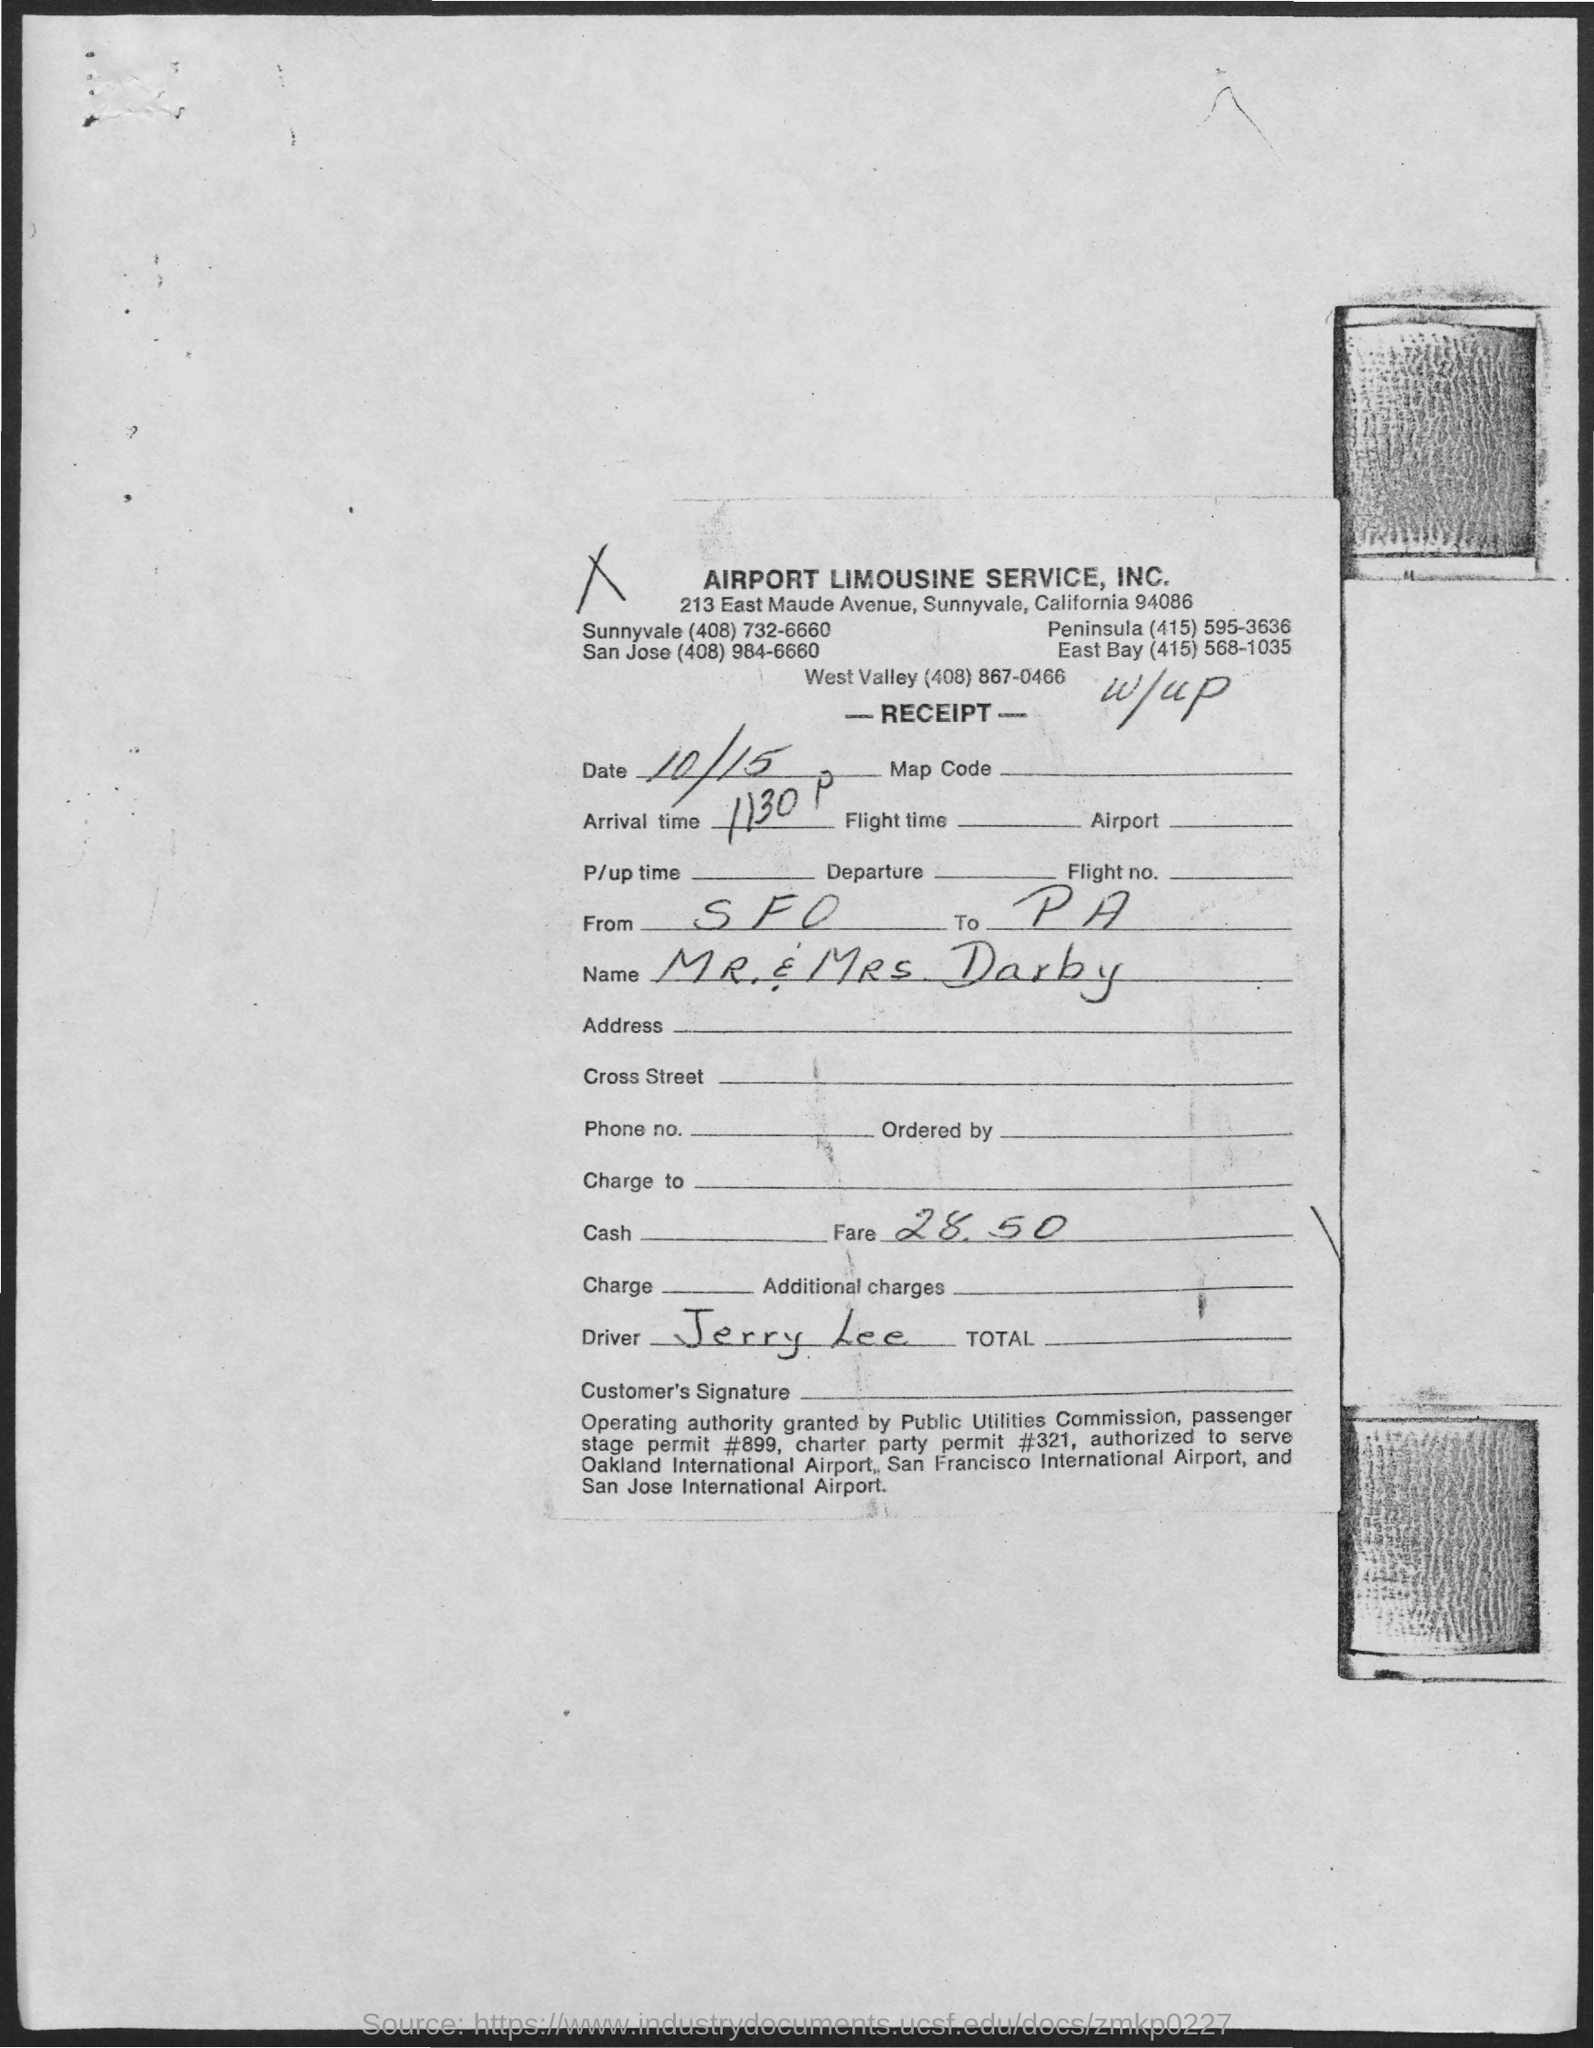What is the oraganisation name?
Make the answer very short. AIRPORT LIMOUSINE SERVICE, INC. What is the name of the traveller?
Provide a short and direct response. MR & MRS DARBY. What is the Fare amount?
Your answer should be very brief. 28.50. 